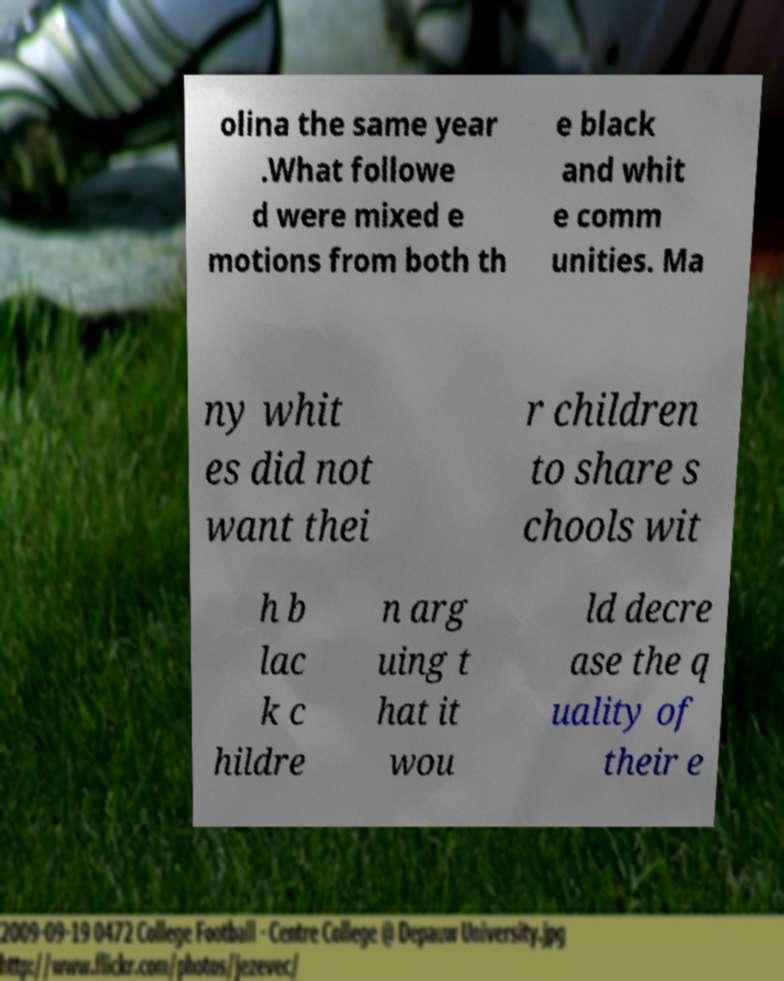Please identify and transcribe the text found in this image. olina the same year .What followe d were mixed e motions from both th e black and whit e comm unities. Ma ny whit es did not want thei r children to share s chools wit h b lac k c hildre n arg uing t hat it wou ld decre ase the q uality of their e 